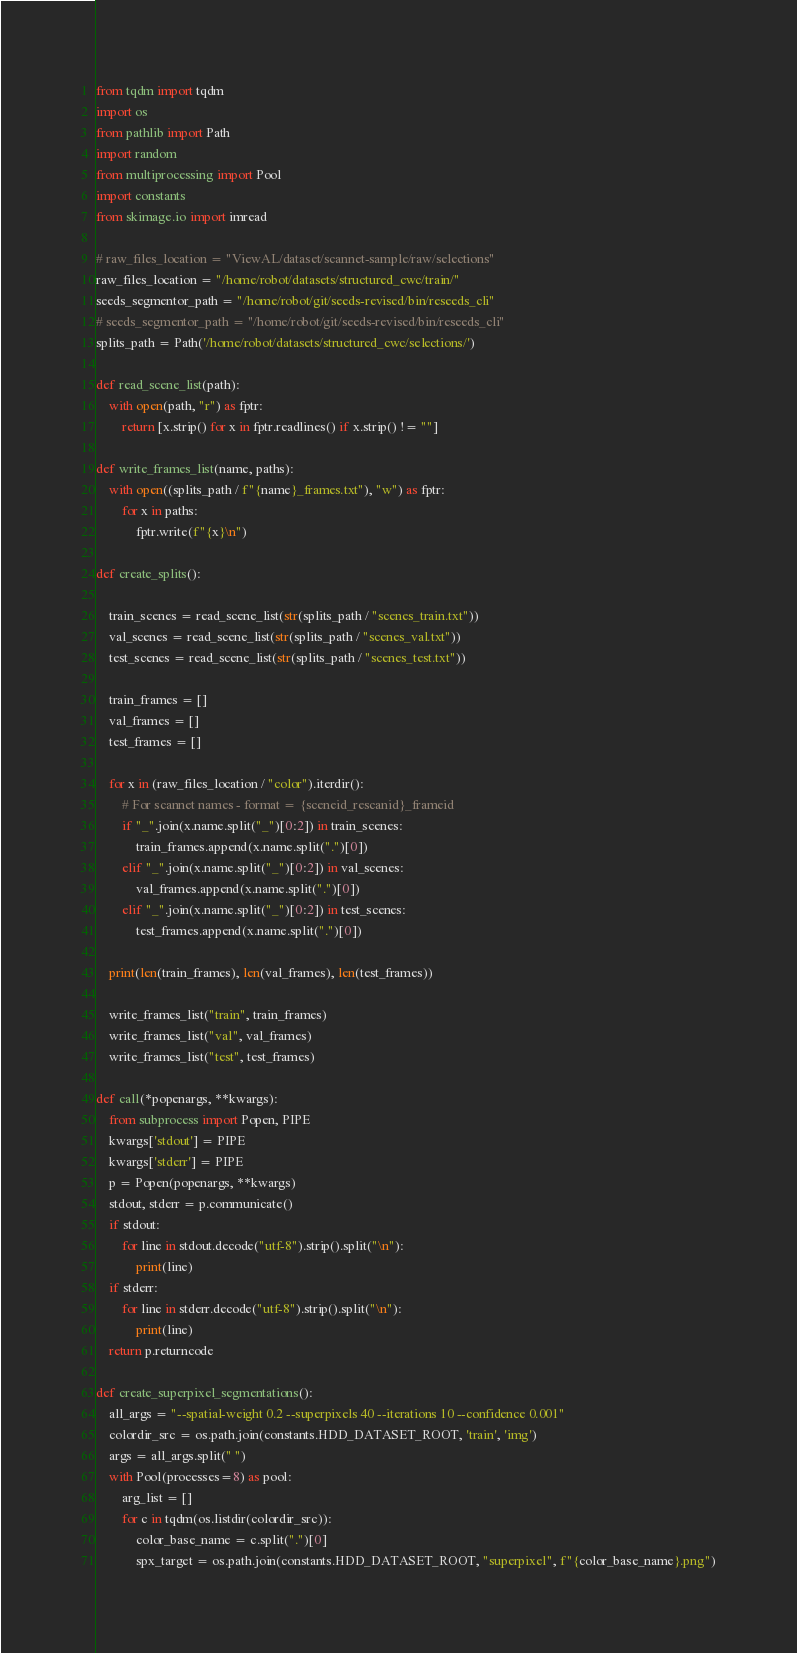<code> <loc_0><loc_0><loc_500><loc_500><_Python_>from tqdm import tqdm
import os
from pathlib import Path
import random
from multiprocessing import Pool
import constants
from skimage.io import imread
    
# raw_files_location = "ViewAL/dataset/scannet-sample/raw/selections"
raw_files_location = "/home/robot/datasets/structured_cwc/train/"
seeds_segmentor_path = "/home/robot/git/seeds-revised/bin/reseeds_cli"
# seeds_segmentor_path = "/home/robot/git/seeds-revised/bin/reseeds_cli"
splits_path = Path('/home/robot/datasets/structured_cwc/selections/')

def read_scene_list(path):
    with open(path, "r") as fptr:
        return [x.strip() for x in fptr.readlines() if x.strip() != ""]

def write_frames_list(name, paths):
    with open((splits_path / f"{name}_frames.txt"), "w") as fptr:
        for x in paths:
            fptr.write(f"{x}\n")

def create_splits():

    train_scenes = read_scene_list(str(splits_path / "scenes_train.txt"))
    val_scenes = read_scene_list(str(splits_path / "scenes_val.txt"))
    test_scenes = read_scene_list(str(splits_path / "scenes_test.txt"))

    train_frames = []
    val_frames = []
    test_frames = []

    for x in (raw_files_location / "color").iterdir():
        # For scannet names - format = {sceneid_rescanid}_frameid
        if "_".join(x.name.split("_")[0:2]) in train_scenes:
            train_frames.append(x.name.split(".")[0])
        elif "_".join(x.name.split("_")[0:2]) in val_scenes:
            val_frames.append(x.name.split(".")[0])
        elif "_".join(x.name.split("_")[0:2]) in test_scenes:
            test_frames.append(x.name.split(".")[0])

    print(len(train_frames), len(val_frames), len(test_frames))

    write_frames_list("train", train_frames)
    write_frames_list("val", val_frames)
    write_frames_list("test", test_frames)

def call(*popenargs, **kwargs):
    from subprocess import Popen, PIPE
    kwargs['stdout'] = PIPE
    kwargs['stderr'] = PIPE
    p = Popen(popenargs, **kwargs)
    stdout, stderr = p.communicate()
    if stdout:
        for line in stdout.decode("utf-8").strip().split("\n"):
            print(line)
    if stderr:
        for line in stderr.decode("utf-8").strip().split("\n"):
            print(line)
    return p.returncode

def create_superpixel_segmentations():
    all_args = "--spatial-weight 0.2 --superpixels 40 --iterations 10 --confidence 0.001"
    colordir_src = os.path.join(constants.HDD_DATASET_ROOT, 'train', 'img')
    args = all_args.split(" ")
    with Pool(processes=8) as pool:
        arg_list = []
        for c in tqdm(os.listdir(colordir_src)):
            color_base_name = c.split(".")[0]
            spx_target = os.path.join(constants.HDD_DATASET_ROOT, "superpixel", f"{color_base_name}.png")</code> 